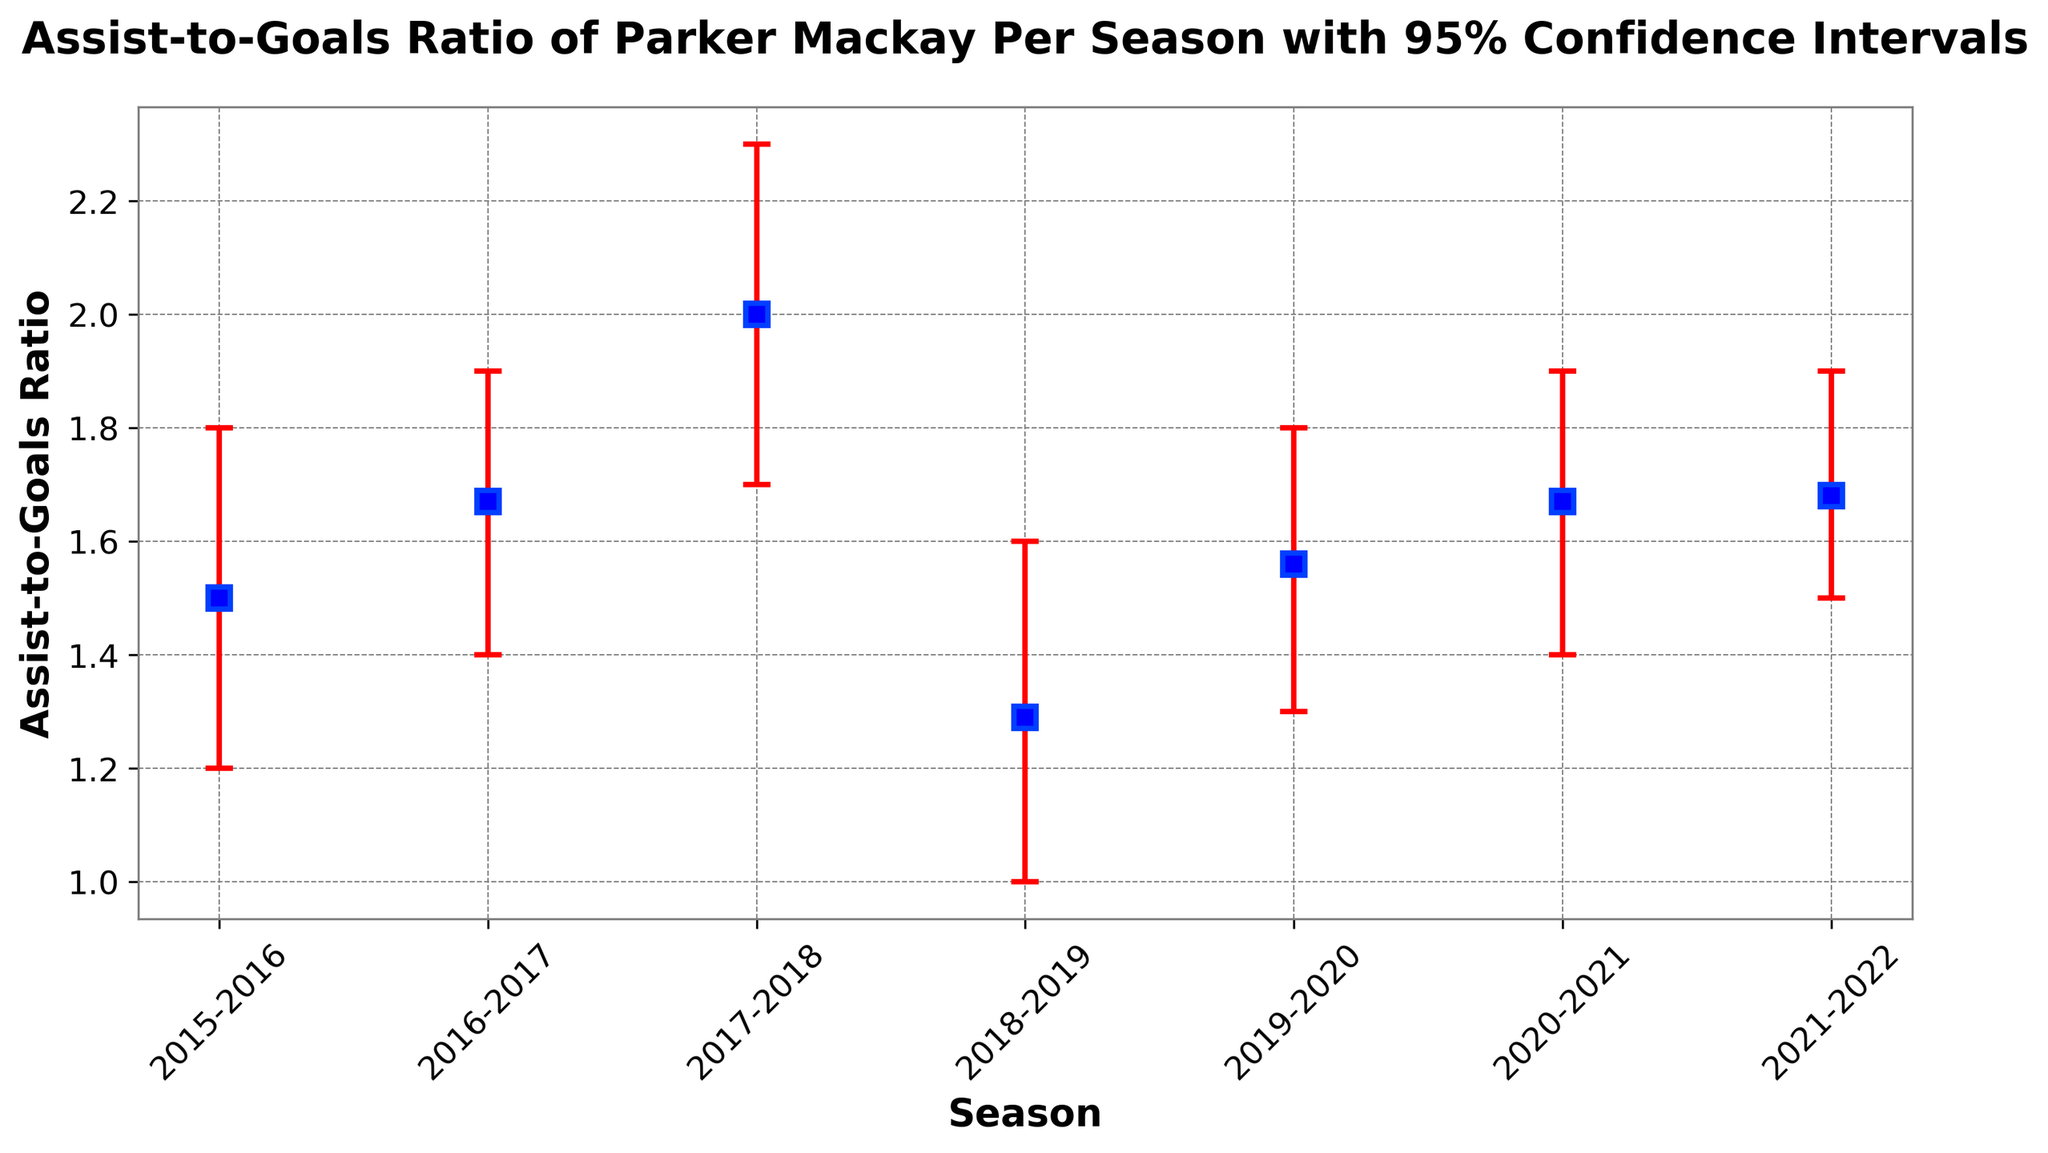what is the highest Assist-to-Goals Ratio for Parker Mackay? The highest ratio is visible on the plot, which is the tallest data point. It corresponds to the 2017-2018 season with a ratio of 2.0
Answer: 2.0 How did Parker Mackay's Assist-to-Goals Ratio change from the 2018-2019 season to the 2019-2020 season? The ratio for 2018-2019 is 1.29 and for 2019-2020 is 1.56. The difference is 1.56 - 1.29.
Answer: It increased by 0.27 Which season has the lowest Assist-to-Goals Ratio? The lowest data point on the plot represents the 2018-2019 season with a ratio of 1.29
Answer: 2018-2019 How consistent was Parker Mackay's performance in 2016-2017 and 2020-2021 in terms of Assist-to-Goals Ratio, considering the confidence intervals? The confidence intervals (1.4 to 1.9) for both seasons overlap completely, indicating similar performance consistency.
Answer: Very consistent What is the average Assist-to-Goals Ratio over all seasons depicted in the plot? The sum of the ratios for all seasons is 1.5 + 1.67 + 2.0 + 1.29 + 1.56 + 1.67 + 1.68 = 11.37. There are 7 seasons, so the average is 11.37 / 7
Answer: Approximately 1.62 Is there a clear upward or downward trend in Parker Mackay's Assist-to-Goals Ratio from 2015 to 2022? Observing the plot, the ratios fluctuate rather than showing a consistent upward or downward trend.
Answer: No clear trend Which two consecutive seasons had the greatest change in Assist-to-Goals Ratio? Observing the plot for the largest difference between two consecutive seasons, the change from 2016-2017 (1.67) to 2017-2018 (2.0) is the greatest, which is 2.0 - 1.67
Answer: 2016-2017 to 2017-2018 Is there any season where the Assist-to-Goals Ratio is exactly between its confidence interval range? No, the ratio is always either closer to the lower or upper bound within each confidence interval range rather than exactly between the two.
Answer: No 